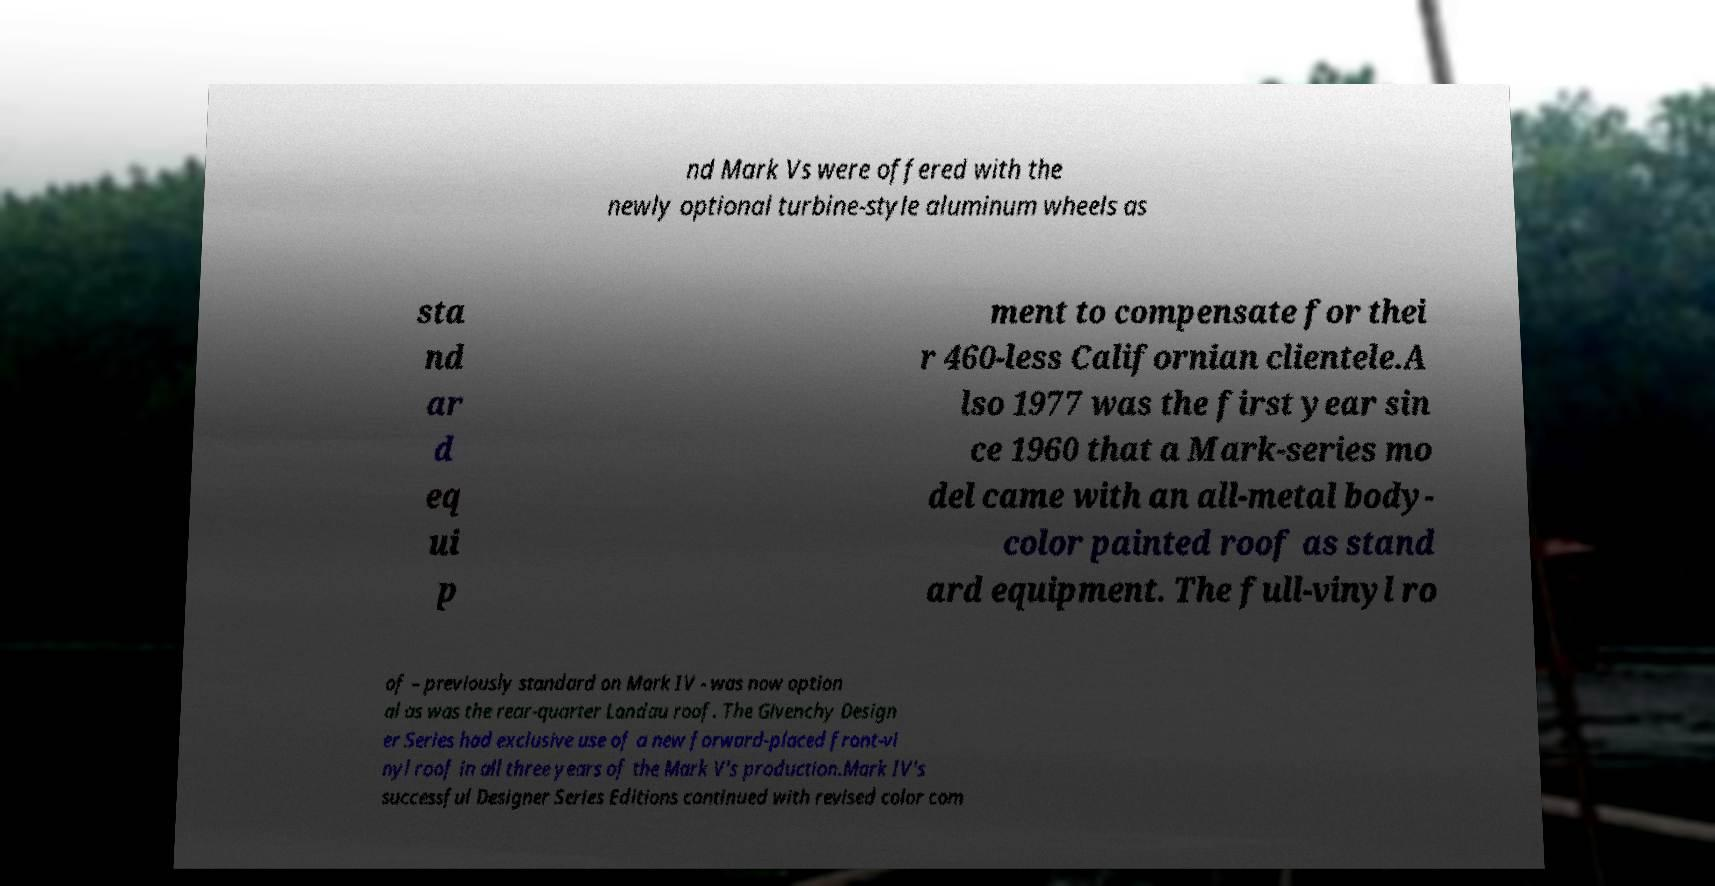Can you accurately transcribe the text from the provided image for me? nd Mark Vs were offered with the newly optional turbine-style aluminum wheels as sta nd ar d eq ui p ment to compensate for thei r 460-less Californian clientele.A lso 1977 was the first year sin ce 1960 that a Mark-series mo del came with an all-metal body- color painted roof as stand ard equipment. The full-vinyl ro of – previously standard on Mark IV - was now option al as was the rear-quarter Landau roof. The Givenchy Design er Series had exclusive use of a new forward-placed front-vi nyl roof in all three years of the Mark V's production.Mark IV's successful Designer Series Editions continued with revised color com 